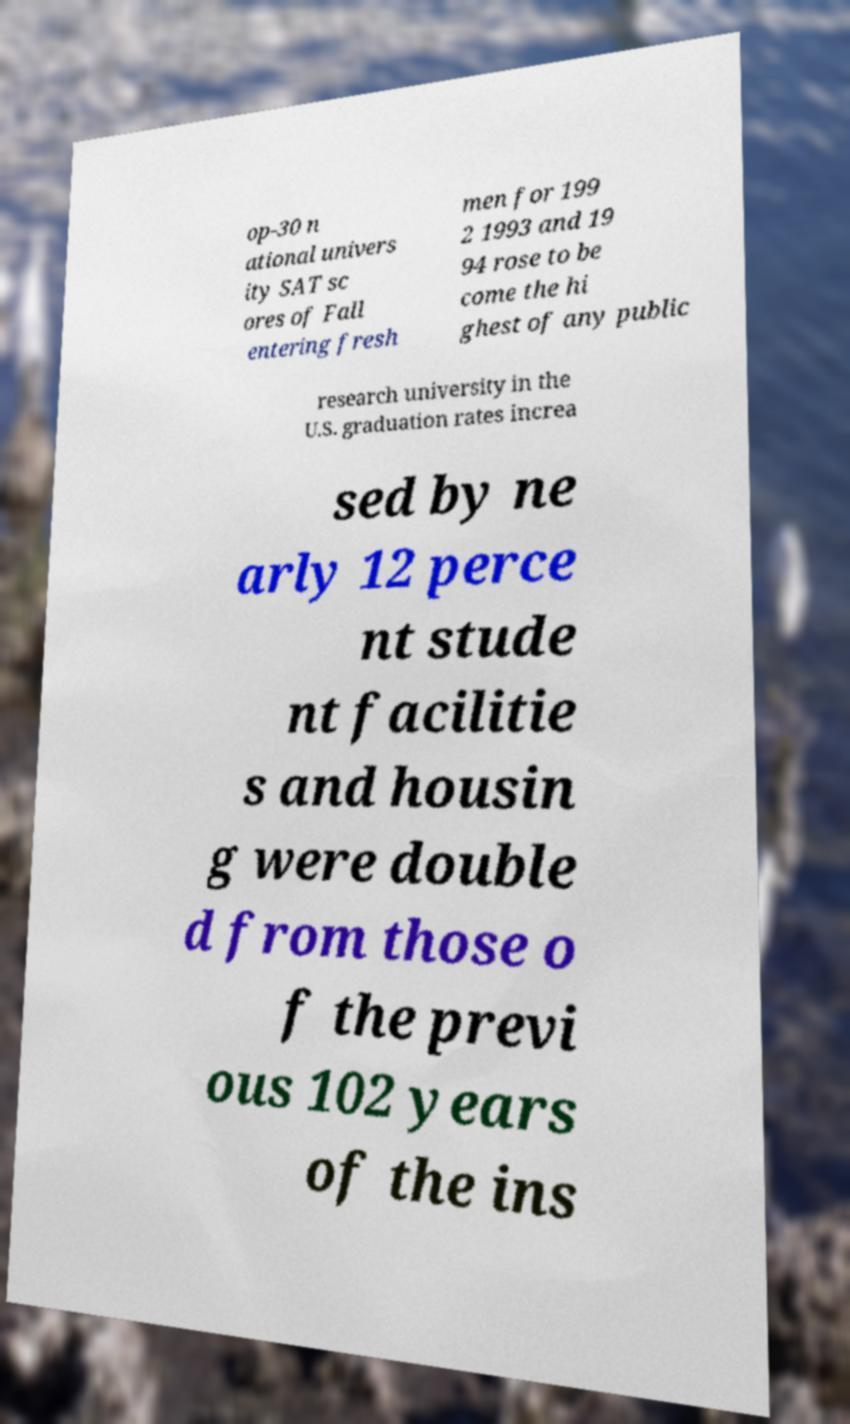Can you accurately transcribe the text from the provided image for me? op-30 n ational univers ity SAT sc ores of Fall entering fresh men for 199 2 1993 and 19 94 rose to be come the hi ghest of any public research university in the U.S. graduation rates increa sed by ne arly 12 perce nt stude nt facilitie s and housin g were double d from those o f the previ ous 102 years of the ins 